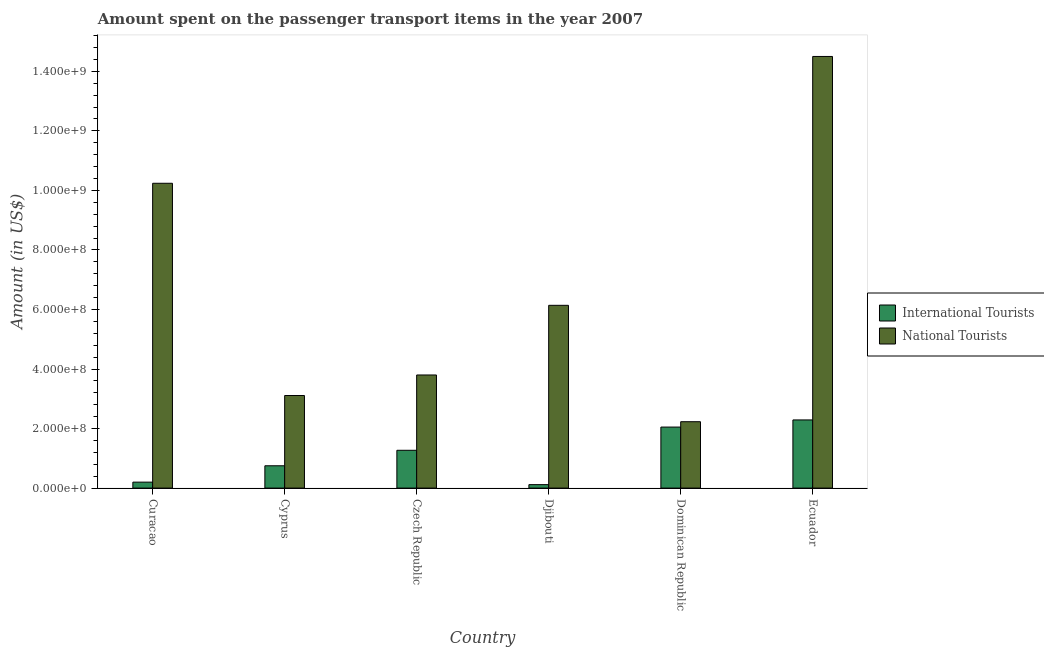How many different coloured bars are there?
Offer a very short reply. 2. What is the label of the 2nd group of bars from the left?
Keep it short and to the point. Cyprus. In how many cases, is the number of bars for a given country not equal to the number of legend labels?
Your answer should be compact. 0. What is the amount spent on transport items of national tourists in Czech Republic?
Give a very brief answer. 3.80e+08. Across all countries, what is the maximum amount spent on transport items of international tourists?
Your answer should be compact. 2.29e+08. Across all countries, what is the minimum amount spent on transport items of international tourists?
Provide a succinct answer. 1.16e+07. In which country was the amount spent on transport items of national tourists maximum?
Offer a very short reply. Ecuador. In which country was the amount spent on transport items of national tourists minimum?
Ensure brevity in your answer.  Dominican Republic. What is the total amount spent on transport items of international tourists in the graph?
Keep it short and to the point. 6.68e+08. What is the difference between the amount spent on transport items of national tourists in Cyprus and that in Djibouti?
Your answer should be compact. -3.03e+08. What is the difference between the amount spent on transport items of national tourists in Cyprus and the amount spent on transport items of international tourists in Dominican Republic?
Your answer should be very brief. 1.06e+08. What is the average amount spent on transport items of international tourists per country?
Provide a short and direct response. 1.11e+08. What is the difference between the amount spent on transport items of international tourists and amount spent on transport items of national tourists in Ecuador?
Keep it short and to the point. -1.22e+09. What is the ratio of the amount spent on transport items of national tourists in Cyprus to that in Czech Republic?
Your answer should be very brief. 0.82. Is the amount spent on transport items of international tourists in Cyprus less than that in Ecuador?
Keep it short and to the point. Yes. Is the difference between the amount spent on transport items of national tourists in Curacao and Djibouti greater than the difference between the amount spent on transport items of international tourists in Curacao and Djibouti?
Provide a short and direct response. Yes. What is the difference between the highest and the second highest amount spent on transport items of national tourists?
Your answer should be compact. 4.26e+08. What is the difference between the highest and the lowest amount spent on transport items of international tourists?
Your answer should be compact. 2.17e+08. Is the sum of the amount spent on transport items of national tourists in Czech Republic and Dominican Republic greater than the maximum amount spent on transport items of international tourists across all countries?
Give a very brief answer. Yes. What does the 2nd bar from the left in Curacao represents?
Offer a terse response. National Tourists. What does the 2nd bar from the right in Djibouti represents?
Your answer should be compact. International Tourists. How many countries are there in the graph?
Your answer should be compact. 6. Are the values on the major ticks of Y-axis written in scientific E-notation?
Keep it short and to the point. Yes. Does the graph contain any zero values?
Your answer should be compact. No. How many legend labels are there?
Ensure brevity in your answer.  2. How are the legend labels stacked?
Provide a short and direct response. Vertical. What is the title of the graph?
Your response must be concise. Amount spent on the passenger transport items in the year 2007. Does "Net savings(excluding particulate emission damage)" appear as one of the legend labels in the graph?
Offer a very short reply. No. What is the label or title of the X-axis?
Your answer should be compact. Country. What is the label or title of the Y-axis?
Ensure brevity in your answer.  Amount (in US$). What is the Amount (in US$) of International Tourists in Curacao?
Keep it short and to the point. 2.00e+07. What is the Amount (in US$) of National Tourists in Curacao?
Provide a short and direct response. 1.02e+09. What is the Amount (in US$) of International Tourists in Cyprus?
Keep it short and to the point. 7.50e+07. What is the Amount (in US$) of National Tourists in Cyprus?
Make the answer very short. 3.11e+08. What is the Amount (in US$) of International Tourists in Czech Republic?
Offer a very short reply. 1.27e+08. What is the Amount (in US$) in National Tourists in Czech Republic?
Offer a very short reply. 3.80e+08. What is the Amount (in US$) in International Tourists in Djibouti?
Give a very brief answer. 1.16e+07. What is the Amount (in US$) in National Tourists in Djibouti?
Provide a succinct answer. 6.14e+08. What is the Amount (in US$) of International Tourists in Dominican Republic?
Ensure brevity in your answer.  2.05e+08. What is the Amount (in US$) in National Tourists in Dominican Republic?
Ensure brevity in your answer.  2.23e+08. What is the Amount (in US$) in International Tourists in Ecuador?
Ensure brevity in your answer.  2.29e+08. What is the Amount (in US$) in National Tourists in Ecuador?
Your answer should be very brief. 1.45e+09. Across all countries, what is the maximum Amount (in US$) in International Tourists?
Offer a terse response. 2.29e+08. Across all countries, what is the maximum Amount (in US$) of National Tourists?
Make the answer very short. 1.45e+09. Across all countries, what is the minimum Amount (in US$) in International Tourists?
Your answer should be compact. 1.16e+07. Across all countries, what is the minimum Amount (in US$) of National Tourists?
Ensure brevity in your answer.  2.23e+08. What is the total Amount (in US$) in International Tourists in the graph?
Offer a terse response. 6.68e+08. What is the total Amount (in US$) in National Tourists in the graph?
Keep it short and to the point. 4.00e+09. What is the difference between the Amount (in US$) in International Tourists in Curacao and that in Cyprus?
Provide a short and direct response. -5.50e+07. What is the difference between the Amount (in US$) in National Tourists in Curacao and that in Cyprus?
Give a very brief answer. 7.13e+08. What is the difference between the Amount (in US$) of International Tourists in Curacao and that in Czech Republic?
Provide a succinct answer. -1.07e+08. What is the difference between the Amount (in US$) in National Tourists in Curacao and that in Czech Republic?
Make the answer very short. 6.44e+08. What is the difference between the Amount (in US$) of International Tourists in Curacao and that in Djibouti?
Keep it short and to the point. 8.40e+06. What is the difference between the Amount (in US$) of National Tourists in Curacao and that in Djibouti?
Give a very brief answer. 4.10e+08. What is the difference between the Amount (in US$) in International Tourists in Curacao and that in Dominican Republic?
Offer a very short reply. -1.85e+08. What is the difference between the Amount (in US$) of National Tourists in Curacao and that in Dominican Republic?
Your response must be concise. 8.01e+08. What is the difference between the Amount (in US$) in International Tourists in Curacao and that in Ecuador?
Provide a succinct answer. -2.09e+08. What is the difference between the Amount (in US$) of National Tourists in Curacao and that in Ecuador?
Ensure brevity in your answer.  -4.26e+08. What is the difference between the Amount (in US$) in International Tourists in Cyprus and that in Czech Republic?
Your answer should be very brief. -5.20e+07. What is the difference between the Amount (in US$) of National Tourists in Cyprus and that in Czech Republic?
Give a very brief answer. -6.90e+07. What is the difference between the Amount (in US$) in International Tourists in Cyprus and that in Djibouti?
Make the answer very short. 6.34e+07. What is the difference between the Amount (in US$) in National Tourists in Cyprus and that in Djibouti?
Ensure brevity in your answer.  -3.03e+08. What is the difference between the Amount (in US$) of International Tourists in Cyprus and that in Dominican Republic?
Offer a terse response. -1.30e+08. What is the difference between the Amount (in US$) in National Tourists in Cyprus and that in Dominican Republic?
Offer a very short reply. 8.80e+07. What is the difference between the Amount (in US$) of International Tourists in Cyprus and that in Ecuador?
Give a very brief answer. -1.54e+08. What is the difference between the Amount (in US$) of National Tourists in Cyprus and that in Ecuador?
Your response must be concise. -1.14e+09. What is the difference between the Amount (in US$) in International Tourists in Czech Republic and that in Djibouti?
Give a very brief answer. 1.15e+08. What is the difference between the Amount (in US$) of National Tourists in Czech Republic and that in Djibouti?
Your response must be concise. -2.34e+08. What is the difference between the Amount (in US$) in International Tourists in Czech Republic and that in Dominican Republic?
Provide a short and direct response. -7.80e+07. What is the difference between the Amount (in US$) in National Tourists in Czech Republic and that in Dominican Republic?
Your answer should be very brief. 1.57e+08. What is the difference between the Amount (in US$) of International Tourists in Czech Republic and that in Ecuador?
Give a very brief answer. -1.02e+08. What is the difference between the Amount (in US$) in National Tourists in Czech Republic and that in Ecuador?
Provide a short and direct response. -1.07e+09. What is the difference between the Amount (in US$) of International Tourists in Djibouti and that in Dominican Republic?
Your answer should be very brief. -1.93e+08. What is the difference between the Amount (in US$) of National Tourists in Djibouti and that in Dominican Republic?
Provide a short and direct response. 3.91e+08. What is the difference between the Amount (in US$) of International Tourists in Djibouti and that in Ecuador?
Keep it short and to the point. -2.17e+08. What is the difference between the Amount (in US$) in National Tourists in Djibouti and that in Ecuador?
Provide a short and direct response. -8.36e+08. What is the difference between the Amount (in US$) in International Tourists in Dominican Republic and that in Ecuador?
Keep it short and to the point. -2.40e+07. What is the difference between the Amount (in US$) in National Tourists in Dominican Republic and that in Ecuador?
Make the answer very short. -1.23e+09. What is the difference between the Amount (in US$) of International Tourists in Curacao and the Amount (in US$) of National Tourists in Cyprus?
Offer a terse response. -2.91e+08. What is the difference between the Amount (in US$) of International Tourists in Curacao and the Amount (in US$) of National Tourists in Czech Republic?
Your answer should be very brief. -3.60e+08. What is the difference between the Amount (in US$) in International Tourists in Curacao and the Amount (in US$) in National Tourists in Djibouti?
Ensure brevity in your answer.  -5.94e+08. What is the difference between the Amount (in US$) in International Tourists in Curacao and the Amount (in US$) in National Tourists in Dominican Republic?
Offer a terse response. -2.03e+08. What is the difference between the Amount (in US$) of International Tourists in Curacao and the Amount (in US$) of National Tourists in Ecuador?
Provide a succinct answer. -1.43e+09. What is the difference between the Amount (in US$) of International Tourists in Cyprus and the Amount (in US$) of National Tourists in Czech Republic?
Make the answer very short. -3.05e+08. What is the difference between the Amount (in US$) in International Tourists in Cyprus and the Amount (in US$) in National Tourists in Djibouti?
Keep it short and to the point. -5.39e+08. What is the difference between the Amount (in US$) in International Tourists in Cyprus and the Amount (in US$) in National Tourists in Dominican Republic?
Keep it short and to the point. -1.48e+08. What is the difference between the Amount (in US$) in International Tourists in Cyprus and the Amount (in US$) in National Tourists in Ecuador?
Offer a very short reply. -1.38e+09. What is the difference between the Amount (in US$) of International Tourists in Czech Republic and the Amount (in US$) of National Tourists in Djibouti?
Make the answer very short. -4.87e+08. What is the difference between the Amount (in US$) in International Tourists in Czech Republic and the Amount (in US$) in National Tourists in Dominican Republic?
Give a very brief answer. -9.60e+07. What is the difference between the Amount (in US$) of International Tourists in Czech Republic and the Amount (in US$) of National Tourists in Ecuador?
Your answer should be very brief. -1.32e+09. What is the difference between the Amount (in US$) in International Tourists in Djibouti and the Amount (in US$) in National Tourists in Dominican Republic?
Make the answer very short. -2.11e+08. What is the difference between the Amount (in US$) of International Tourists in Djibouti and the Amount (in US$) of National Tourists in Ecuador?
Provide a succinct answer. -1.44e+09. What is the difference between the Amount (in US$) of International Tourists in Dominican Republic and the Amount (in US$) of National Tourists in Ecuador?
Give a very brief answer. -1.24e+09. What is the average Amount (in US$) of International Tourists per country?
Keep it short and to the point. 1.11e+08. What is the average Amount (in US$) in National Tourists per country?
Provide a succinct answer. 6.67e+08. What is the difference between the Amount (in US$) in International Tourists and Amount (in US$) in National Tourists in Curacao?
Provide a short and direct response. -1.00e+09. What is the difference between the Amount (in US$) in International Tourists and Amount (in US$) in National Tourists in Cyprus?
Give a very brief answer. -2.36e+08. What is the difference between the Amount (in US$) of International Tourists and Amount (in US$) of National Tourists in Czech Republic?
Give a very brief answer. -2.53e+08. What is the difference between the Amount (in US$) of International Tourists and Amount (in US$) of National Tourists in Djibouti?
Your answer should be very brief. -6.02e+08. What is the difference between the Amount (in US$) of International Tourists and Amount (in US$) of National Tourists in Dominican Republic?
Offer a terse response. -1.80e+07. What is the difference between the Amount (in US$) in International Tourists and Amount (in US$) in National Tourists in Ecuador?
Your response must be concise. -1.22e+09. What is the ratio of the Amount (in US$) in International Tourists in Curacao to that in Cyprus?
Offer a very short reply. 0.27. What is the ratio of the Amount (in US$) in National Tourists in Curacao to that in Cyprus?
Your response must be concise. 3.29. What is the ratio of the Amount (in US$) of International Tourists in Curacao to that in Czech Republic?
Ensure brevity in your answer.  0.16. What is the ratio of the Amount (in US$) in National Tourists in Curacao to that in Czech Republic?
Your answer should be compact. 2.69. What is the ratio of the Amount (in US$) of International Tourists in Curacao to that in Djibouti?
Offer a very short reply. 1.72. What is the ratio of the Amount (in US$) in National Tourists in Curacao to that in Djibouti?
Provide a short and direct response. 1.67. What is the ratio of the Amount (in US$) in International Tourists in Curacao to that in Dominican Republic?
Provide a succinct answer. 0.1. What is the ratio of the Amount (in US$) in National Tourists in Curacao to that in Dominican Republic?
Your answer should be very brief. 4.59. What is the ratio of the Amount (in US$) of International Tourists in Curacao to that in Ecuador?
Provide a succinct answer. 0.09. What is the ratio of the Amount (in US$) in National Tourists in Curacao to that in Ecuador?
Ensure brevity in your answer.  0.71. What is the ratio of the Amount (in US$) of International Tourists in Cyprus to that in Czech Republic?
Make the answer very short. 0.59. What is the ratio of the Amount (in US$) in National Tourists in Cyprus to that in Czech Republic?
Keep it short and to the point. 0.82. What is the ratio of the Amount (in US$) in International Tourists in Cyprus to that in Djibouti?
Provide a short and direct response. 6.47. What is the ratio of the Amount (in US$) of National Tourists in Cyprus to that in Djibouti?
Your answer should be very brief. 0.51. What is the ratio of the Amount (in US$) of International Tourists in Cyprus to that in Dominican Republic?
Offer a very short reply. 0.37. What is the ratio of the Amount (in US$) of National Tourists in Cyprus to that in Dominican Republic?
Provide a short and direct response. 1.39. What is the ratio of the Amount (in US$) in International Tourists in Cyprus to that in Ecuador?
Keep it short and to the point. 0.33. What is the ratio of the Amount (in US$) in National Tourists in Cyprus to that in Ecuador?
Give a very brief answer. 0.21. What is the ratio of the Amount (in US$) of International Tourists in Czech Republic to that in Djibouti?
Your answer should be compact. 10.95. What is the ratio of the Amount (in US$) in National Tourists in Czech Republic to that in Djibouti?
Your answer should be compact. 0.62. What is the ratio of the Amount (in US$) of International Tourists in Czech Republic to that in Dominican Republic?
Give a very brief answer. 0.62. What is the ratio of the Amount (in US$) of National Tourists in Czech Republic to that in Dominican Republic?
Ensure brevity in your answer.  1.7. What is the ratio of the Amount (in US$) in International Tourists in Czech Republic to that in Ecuador?
Make the answer very short. 0.55. What is the ratio of the Amount (in US$) in National Tourists in Czech Republic to that in Ecuador?
Keep it short and to the point. 0.26. What is the ratio of the Amount (in US$) of International Tourists in Djibouti to that in Dominican Republic?
Your answer should be very brief. 0.06. What is the ratio of the Amount (in US$) of National Tourists in Djibouti to that in Dominican Republic?
Provide a succinct answer. 2.75. What is the ratio of the Amount (in US$) of International Tourists in Djibouti to that in Ecuador?
Provide a succinct answer. 0.05. What is the ratio of the Amount (in US$) in National Tourists in Djibouti to that in Ecuador?
Your response must be concise. 0.42. What is the ratio of the Amount (in US$) of International Tourists in Dominican Republic to that in Ecuador?
Give a very brief answer. 0.9. What is the ratio of the Amount (in US$) in National Tourists in Dominican Republic to that in Ecuador?
Offer a terse response. 0.15. What is the difference between the highest and the second highest Amount (in US$) of International Tourists?
Your answer should be compact. 2.40e+07. What is the difference between the highest and the second highest Amount (in US$) of National Tourists?
Provide a short and direct response. 4.26e+08. What is the difference between the highest and the lowest Amount (in US$) in International Tourists?
Provide a succinct answer. 2.17e+08. What is the difference between the highest and the lowest Amount (in US$) of National Tourists?
Your response must be concise. 1.23e+09. 